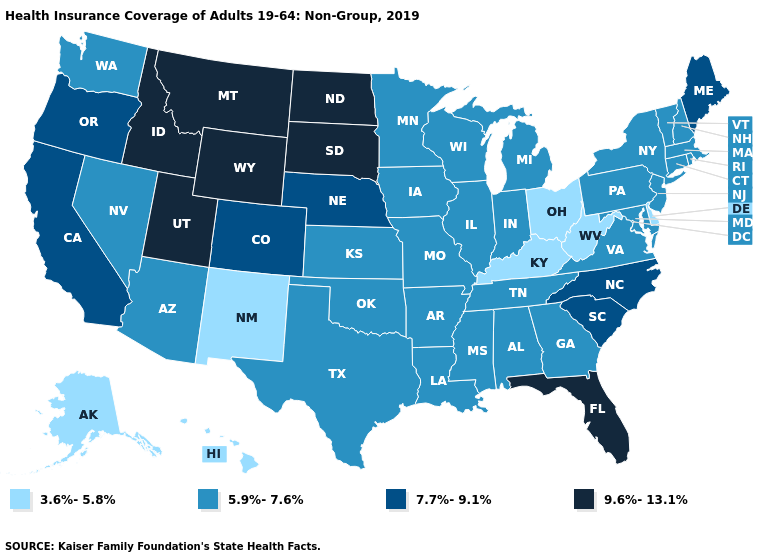Does Nevada have the highest value in the West?
Keep it brief. No. What is the value of Georgia?
Answer briefly. 5.9%-7.6%. Name the states that have a value in the range 9.6%-13.1%?
Quick response, please. Florida, Idaho, Montana, North Dakota, South Dakota, Utah, Wyoming. Does the first symbol in the legend represent the smallest category?
Quick response, please. Yes. Which states have the highest value in the USA?
Answer briefly. Florida, Idaho, Montana, North Dakota, South Dakota, Utah, Wyoming. What is the highest value in the USA?
Keep it brief. 9.6%-13.1%. Which states hav the highest value in the West?
Give a very brief answer. Idaho, Montana, Utah, Wyoming. Which states have the highest value in the USA?
Write a very short answer. Florida, Idaho, Montana, North Dakota, South Dakota, Utah, Wyoming. Does Rhode Island have a lower value than California?
Short answer required. Yes. Does Colorado have the highest value in the West?
Be succinct. No. Is the legend a continuous bar?
Give a very brief answer. No. Does Oregon have the highest value in the USA?
Quick response, please. No. Among the states that border Montana , which have the highest value?
Keep it brief. Idaho, North Dakota, South Dakota, Wyoming. Which states have the highest value in the USA?
Concise answer only. Florida, Idaho, Montana, North Dakota, South Dakota, Utah, Wyoming. What is the value of Vermont?
Answer briefly. 5.9%-7.6%. 